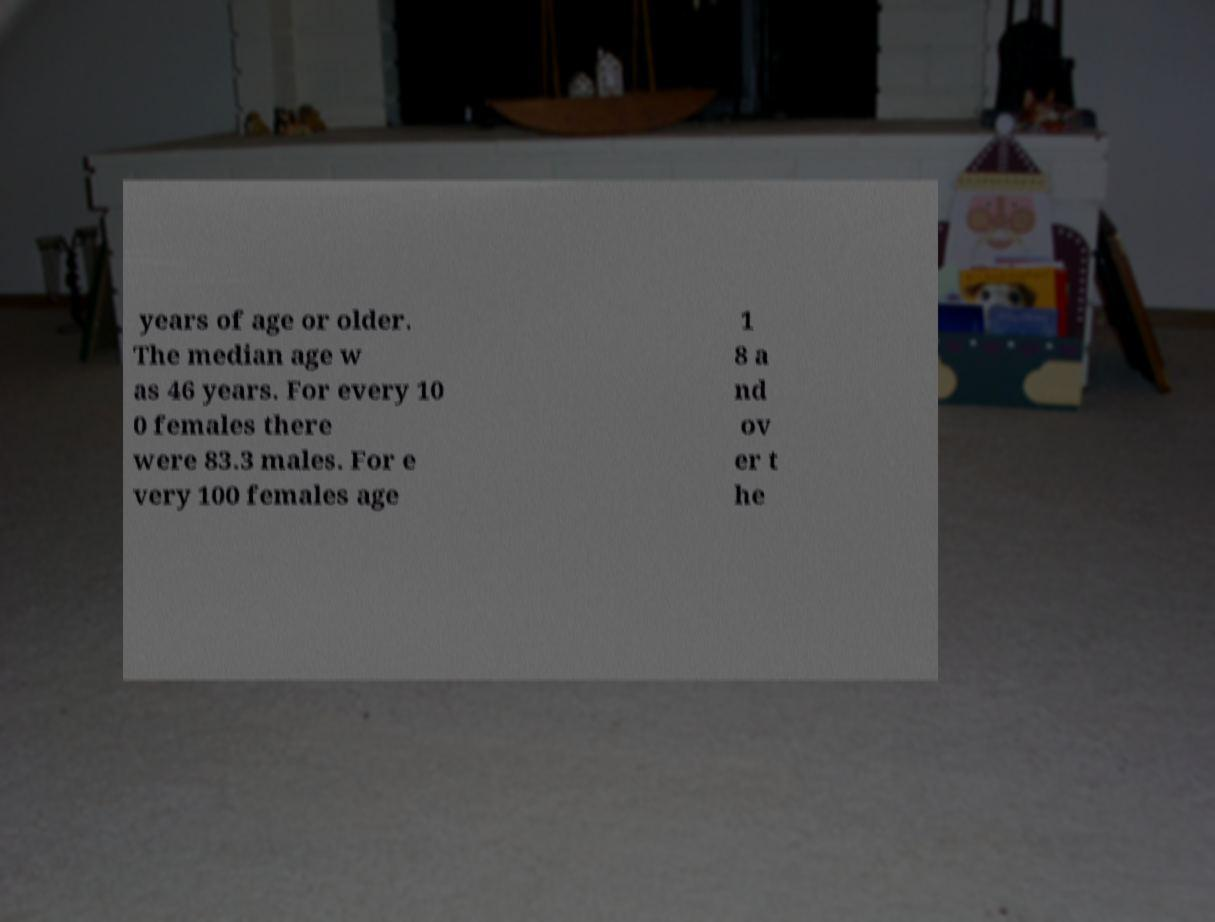What messages or text are displayed in this image? I need them in a readable, typed format. years of age or older. The median age w as 46 years. For every 10 0 females there were 83.3 males. For e very 100 females age 1 8 a nd ov er t he 